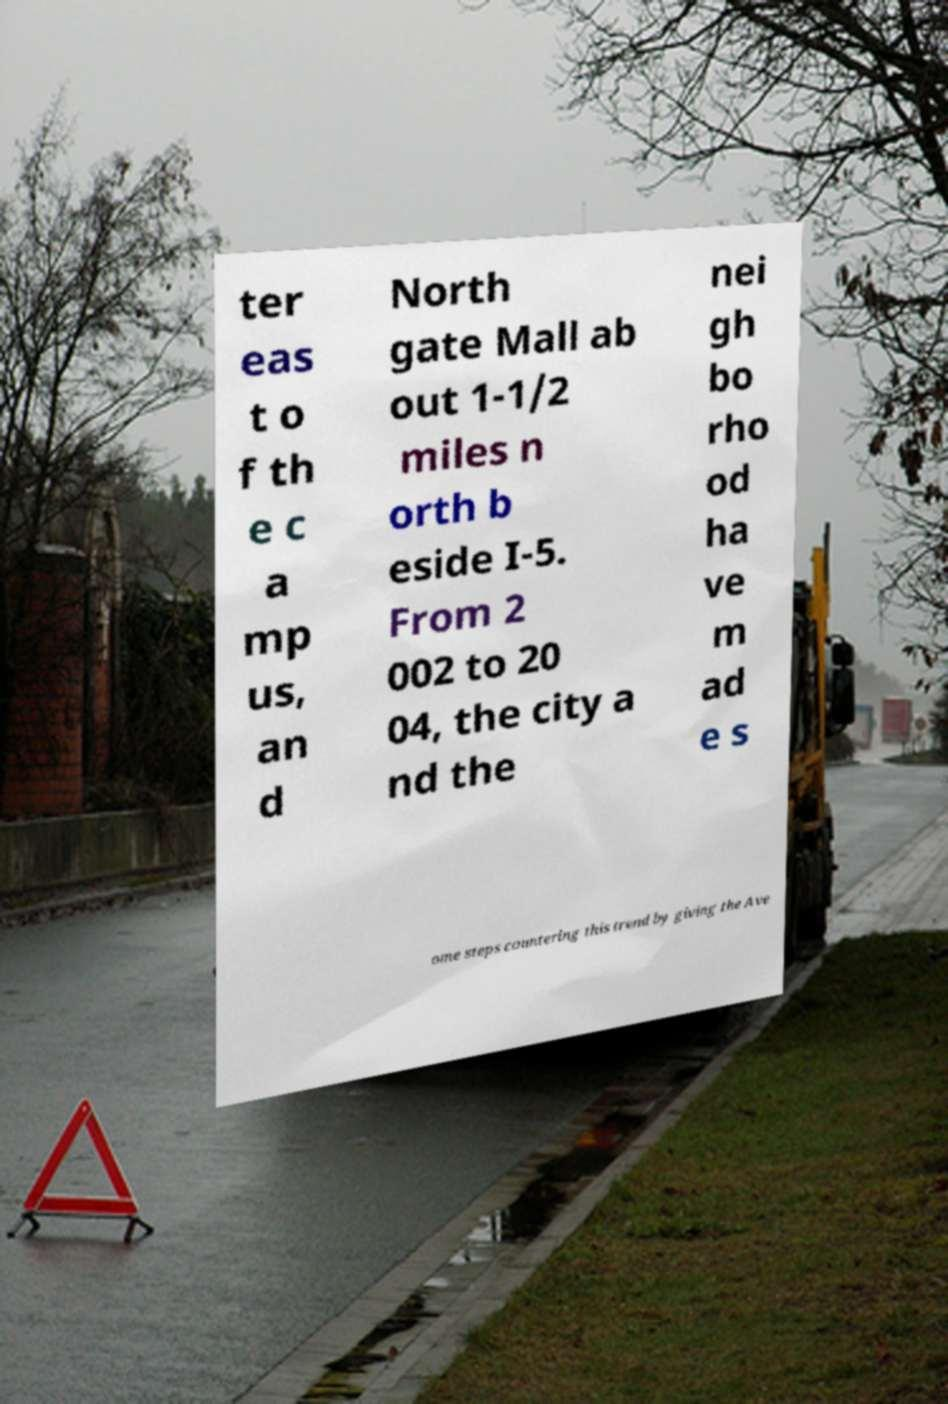There's text embedded in this image that I need extracted. Can you transcribe it verbatim? ter eas t o f th e c a mp us, an d North gate Mall ab out 1-1/2 miles n orth b eside I-5. From 2 002 to 20 04, the city a nd the nei gh bo rho od ha ve m ad e s ome steps countering this trend by giving the Ave 